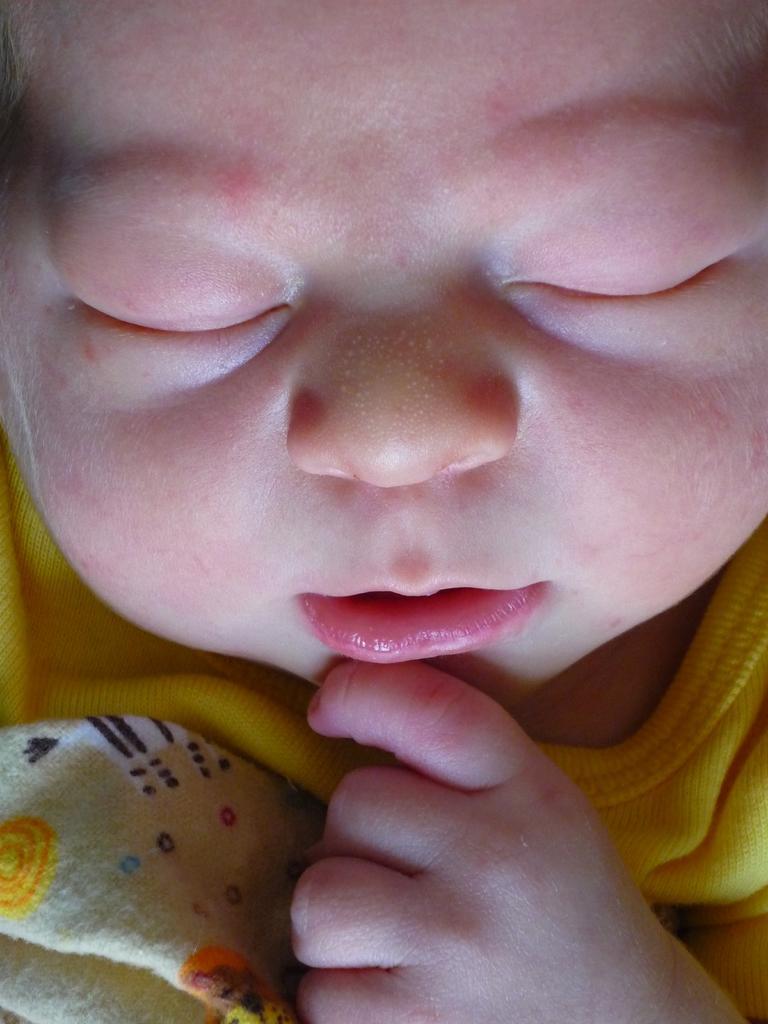Please provide a concise description of this image. In this picture we can see a baby. 